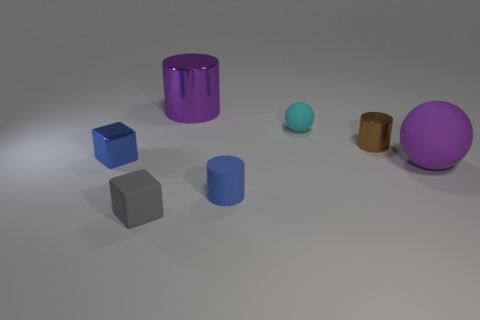Is the material of the ball on the right side of the tiny brown metallic cylinder the same as the small cylinder that is on the right side of the tiny cyan thing?
Ensure brevity in your answer.  No. There is a matte ball that is on the left side of the thing that is to the right of the small cylinder behind the tiny blue matte object; what is its color?
Provide a succinct answer. Cyan. What number of other things are the same shape as the blue shiny thing?
Provide a short and direct response. 1. Does the big metallic object have the same color as the big rubber sphere?
Your answer should be very brief. Yes. How many objects are tiny brown metal balls or tiny rubber objects behind the gray rubber thing?
Your answer should be compact. 2. Are there any other shiny things of the same size as the cyan object?
Give a very brief answer. Yes. Does the purple ball have the same material as the small brown cylinder?
Your answer should be very brief. No. How many objects are purple objects or small cyan rubber things?
Make the answer very short. 3. The purple cylinder is what size?
Your answer should be compact. Large. Are there fewer tiny brown things than big green shiny cylinders?
Make the answer very short. No. 